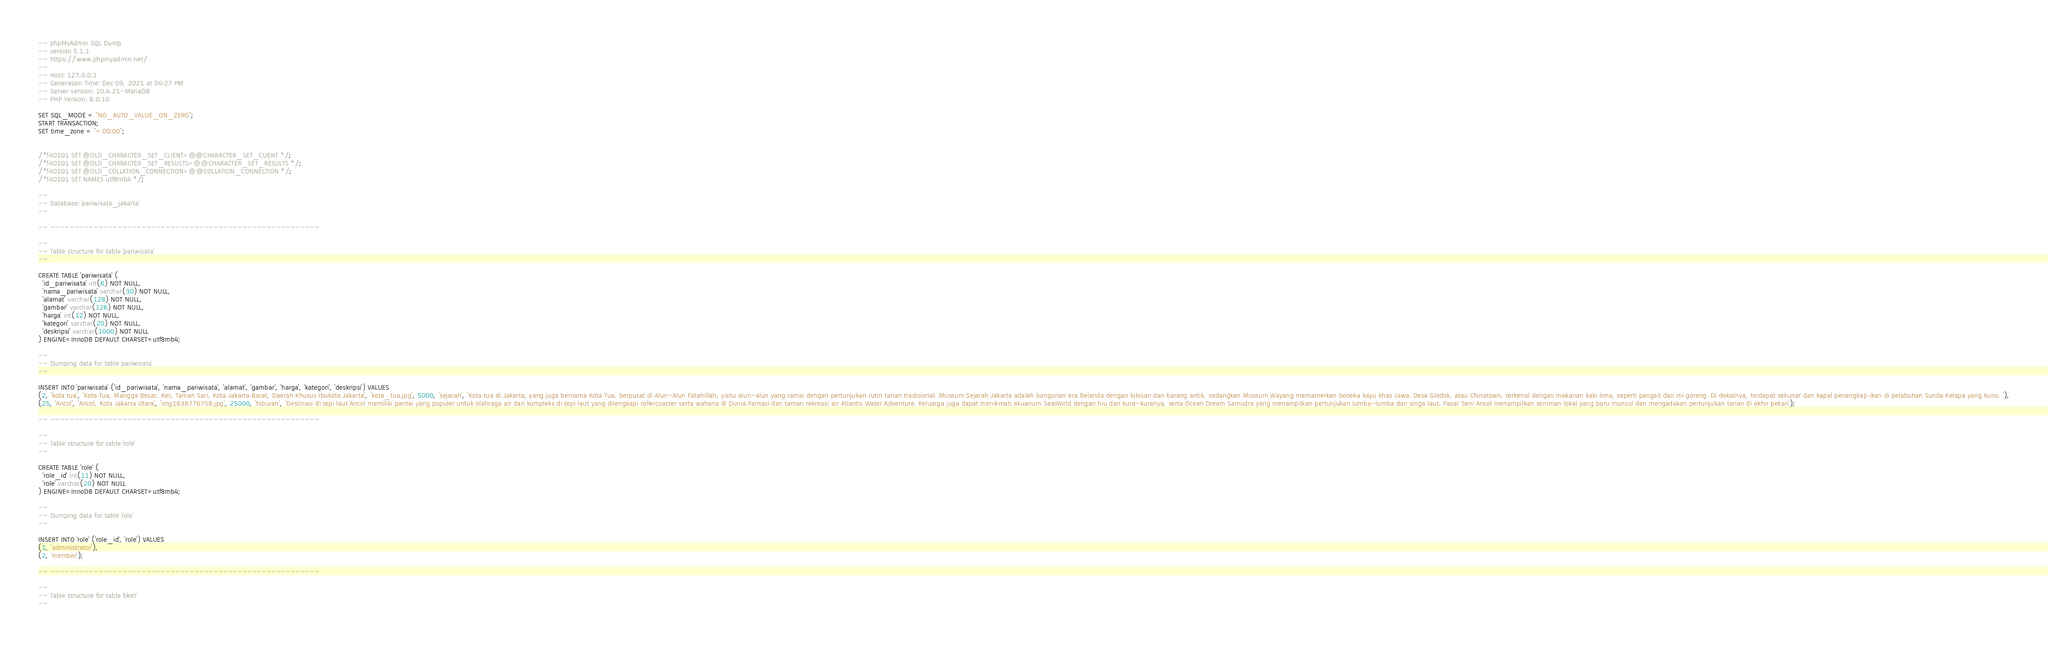<code> <loc_0><loc_0><loc_500><loc_500><_SQL_>-- phpMyAdmin SQL Dump
-- version 5.1.1
-- https://www.phpmyadmin.net/
--
-- Host: 127.0.0.1
-- Generation Time: Dec 09, 2021 at 04:27 PM
-- Server version: 10.4.21-MariaDB
-- PHP Version: 8.0.10

SET SQL_MODE = "NO_AUTO_VALUE_ON_ZERO";
START TRANSACTION;
SET time_zone = "+00:00";


/*!40101 SET @OLD_CHARACTER_SET_CLIENT=@@CHARACTER_SET_CLIENT */;
/*!40101 SET @OLD_CHARACTER_SET_RESULTS=@@CHARACTER_SET_RESULTS */;
/*!40101 SET @OLD_COLLATION_CONNECTION=@@COLLATION_CONNECTION */;
/*!40101 SET NAMES utf8mb4 */;

--
-- Database: `pariwisata_jakarta`
--

-- --------------------------------------------------------

--
-- Table structure for table `pariwisata`
--

CREATE TABLE `pariwisata` (
  `id_pariwisata` int(6) NOT NULL,
  `nama_pariwisata` varchar(30) NOT NULL,
  `alamat` varchar(128) NOT NULL,
  `gambar` varchar(126) NOT NULL,
  `harga` int(12) NOT NULL,
  `kategori` varchar(20) NOT NULL,
  `deskripsi` varchar(1000) NOT NULL
) ENGINE=InnoDB DEFAULT CHARSET=utf8mb4;

--
-- Dumping data for table `pariwisata`
--

INSERT INTO `pariwisata` (`id_pariwisata`, `nama_pariwisata`, `alamat`, `gambar`, `harga`, `kategori`, `deskripsi`) VALUES
(2, 'kota tua', 'Kota Tua, Mangga Besar, Kec. Taman Sari, Kota Jakarta Barat, Daerah Khusus Ibukota Jakarta', 'kota_tua.jpg', 5000, 'sejarah', 'Kota tua di Jakarta, yang juga bernama Kota Tua, berpusat di Alun-Alun Fatahillah, yaitu alun-alun yang ramai dengan pertunjukan rutin tarian tradisional. Museum Sejarah Jakarta adalah bangunan era Belanda dengan lukisan dan barang antik, sedangkan Museum Wayang memamerkan boneka kayu khas Jawa. Desa Glodok, atau Chinatown, terkenal dengan makanan kaki lima, seperti pangsit dan mi goreng. Di dekatnya, terdapat sekunar dan kapal penangkap ikan di pelabuhan Sunda Kelapa yang kuno. '),
(25, 'Ancol', 'Ancol, Kota Jakarta Utara', 'img1638776758.jpg', 25000, 'hiburan', 'Destinasi di tepi laut Ancol memiliki pantai yang populer untuk olahraga air dan kompleks di tepi laut yang dilengkapi rollercoaster serta wahana di Dunia Fantasi dan taman rekreasi air Atlantis Water Adventure. Keluarga juga dapat menikmati akuarium SeaWorld dengan hiu dan kura-kuranya, serta Ocean Dream Samudra yang menampilkan pertunjukan lumba-lumba dan singa laut. Pasar Seni Ancol menampilkan seniman lokal yang baru muncul dan mengadakan pertunjukan tarian di akhir pekan');

-- --------------------------------------------------------

--
-- Table structure for table `role`
--

CREATE TABLE `role` (
  `role_id` int(11) NOT NULL,
  `role` varchar(20) NOT NULL
) ENGINE=InnoDB DEFAULT CHARSET=utf8mb4;

--
-- Dumping data for table `role`
--

INSERT INTO `role` (`role_id`, `role`) VALUES
(1, 'administrator'),
(2, 'member');

-- --------------------------------------------------------

--
-- Table structure for table `tiket`
--
</code> 